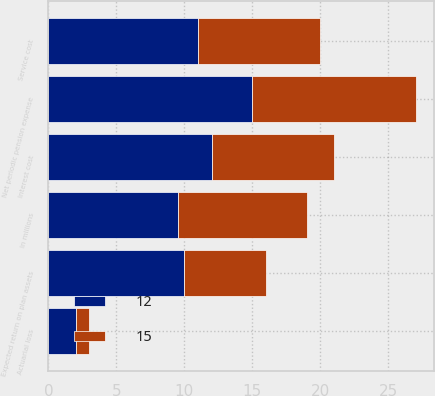Convert chart. <chart><loc_0><loc_0><loc_500><loc_500><stacked_bar_chart><ecel><fcel>In millions<fcel>Service cost<fcel>Interest cost<fcel>Expected return on plan assets<fcel>Actuarial loss<fcel>Net periodic pension expense<nl><fcel>12<fcel>9.5<fcel>11<fcel>12<fcel>10<fcel>2<fcel>15<nl><fcel>15<fcel>9.5<fcel>9<fcel>9<fcel>6<fcel>1<fcel>12<nl></chart> 